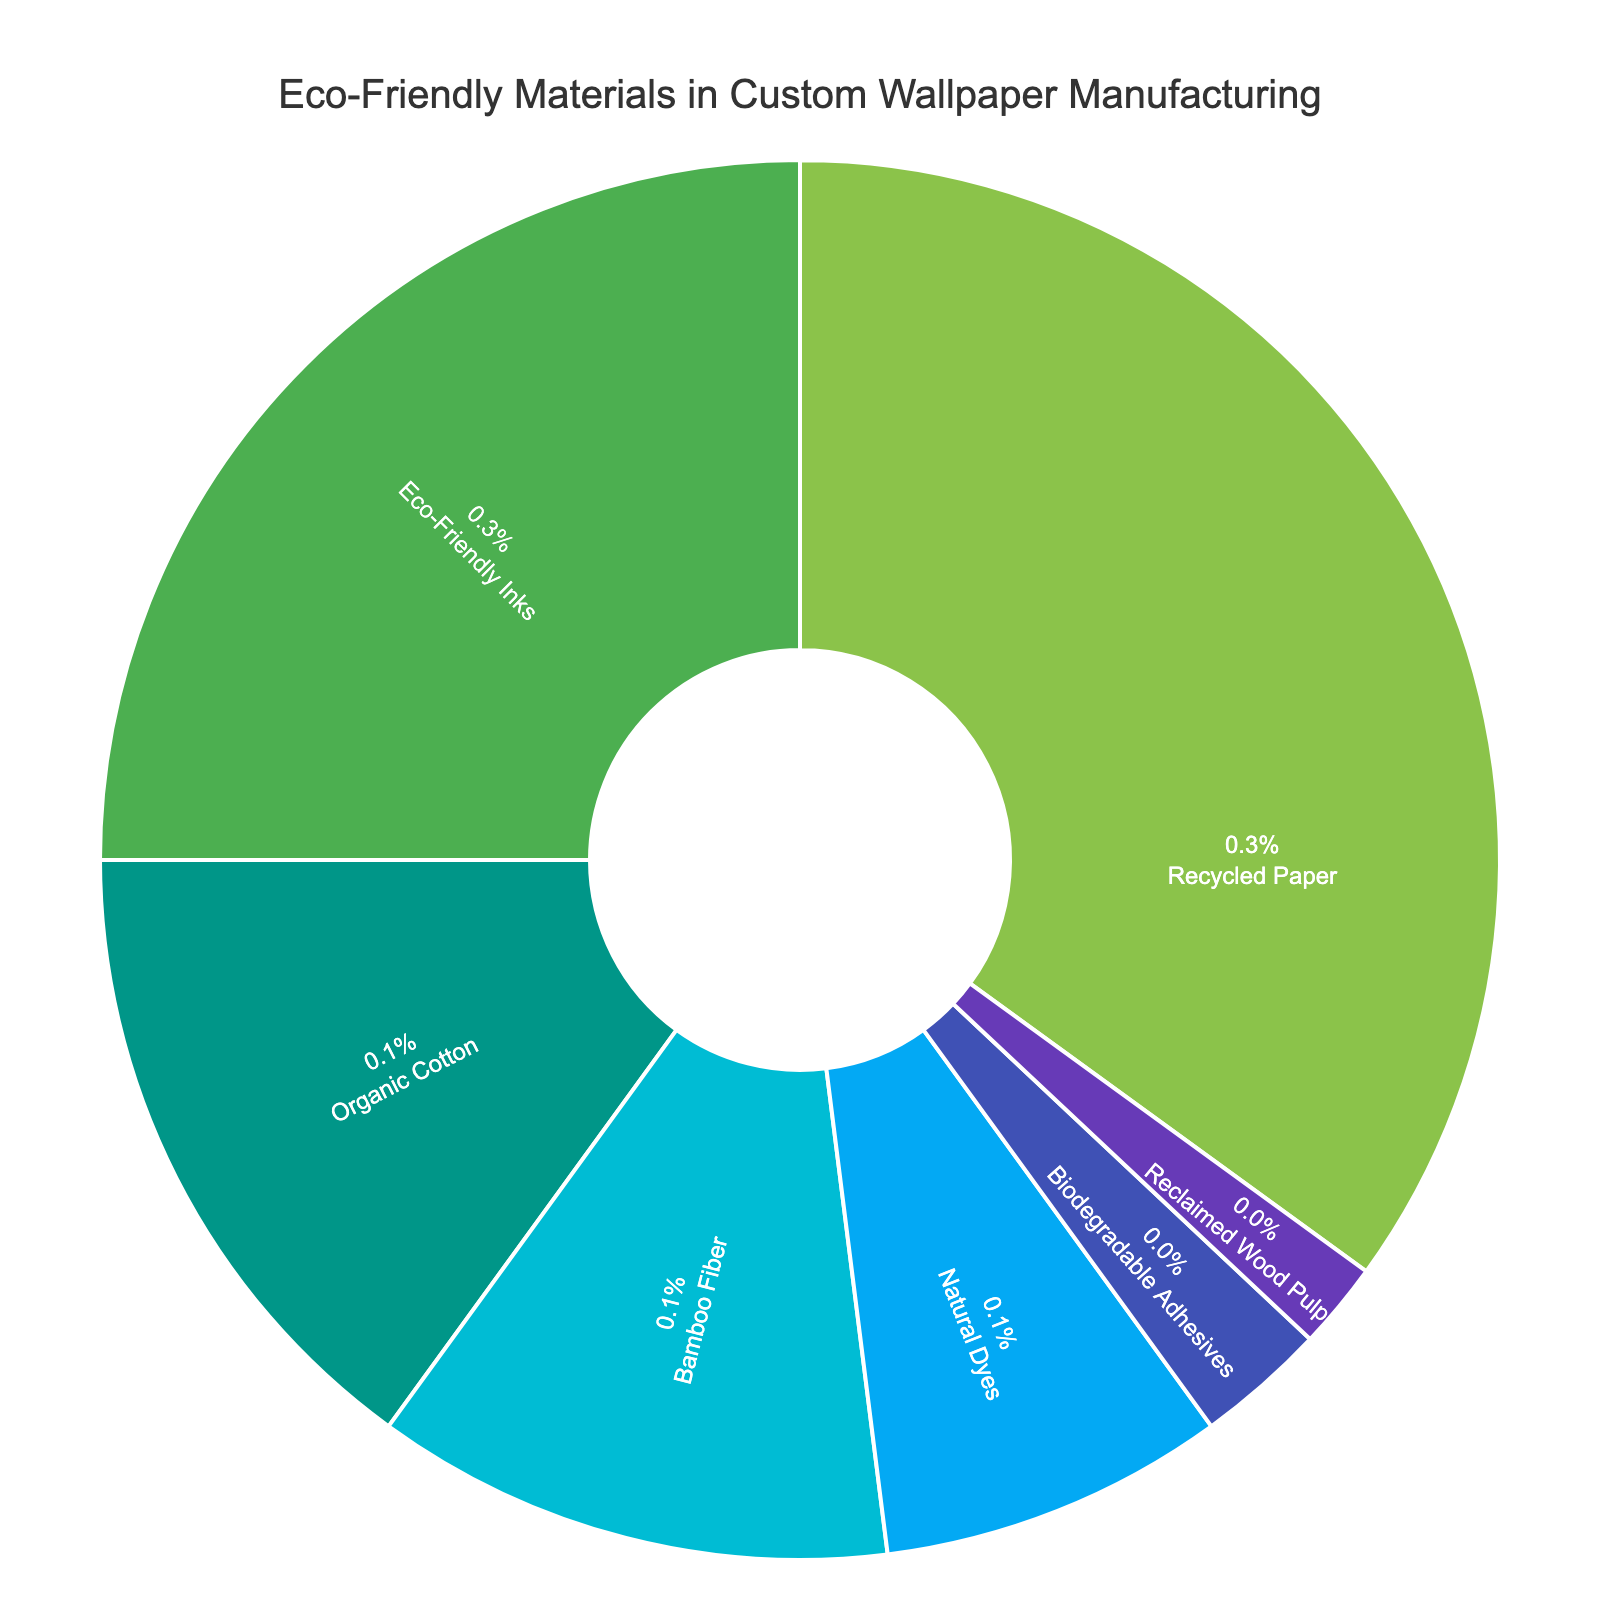What is the most used eco-friendly material in custom wallpaper manufacturing? The pie chart shows that "Recycled Paper" has the largest segment, indicating it is the most used material.
Answer: Recycled Paper Which eco-friendly materials make up over 20% of the total? From the pie chart, "Recycled Paper" and "Eco-Friendly Inks" have percentages of 35% and 25%, respectively, both over 20%.
Answer: Recycled Paper, Eco-Friendly Inks What is the combined percentage of Organic Cotton and Bamboo Fiber? Organic Cotton has a percentage of 15% and Bamboo Fiber has 12%. Adding them together gives 15% + 12% = 27%.
Answer: 27% By how much does the percentage of Eco-Friendly Inks exceed that of Organic Cotton? Eco-Friendly Inks constitute 25% while Organic Cotton constitutes 15%. The difference is 25% - 15% = 10%.
Answer: 10% If you were to combine the percentages of Natural Dyes, Biodegradable Adhesives, and Reclaimed Wood Pulp, what would the total percentage be? Natural Dyes have 8%, Biodegradable Adhesives have 3%, and Reclaimed Wood Pulp has 2%. Adding them together gives 8% + 3% + 2% = 13%.
Answer: 13% Which material is used the least in custom wallpaper manufacturing, based on the pie chart? The pie chart indicates that "Reclaimed Wood Pulp" has the smallest segment, representing the smallest percentage.
Answer: Reclaimed Wood Pulp List the materials that together constitute more than 50% of the total usage. Recycled Paper (35%) and Eco-Friendly Inks (25%) together constitute 60% of the total usage, which is more than 50%.
Answer: Recycled Paper, Eco-Friendly Inks How does the percentage of Bamboo Fiber compare to that of Natural Dyes? Bamboo Fiber has a percentage of 12% while Natural Dyes have 8%. Bamboo Fiber's percentage is greater by 4%.
Answer: Bamboo Fiber's percentage is higher by 4% What material is represented by the dark green segment in the pie chart? The dark green color represents "Eco-Friendly Inks" based on the provided custom color palette and pie chart segments.
Answer: Eco-Friendly Inks 